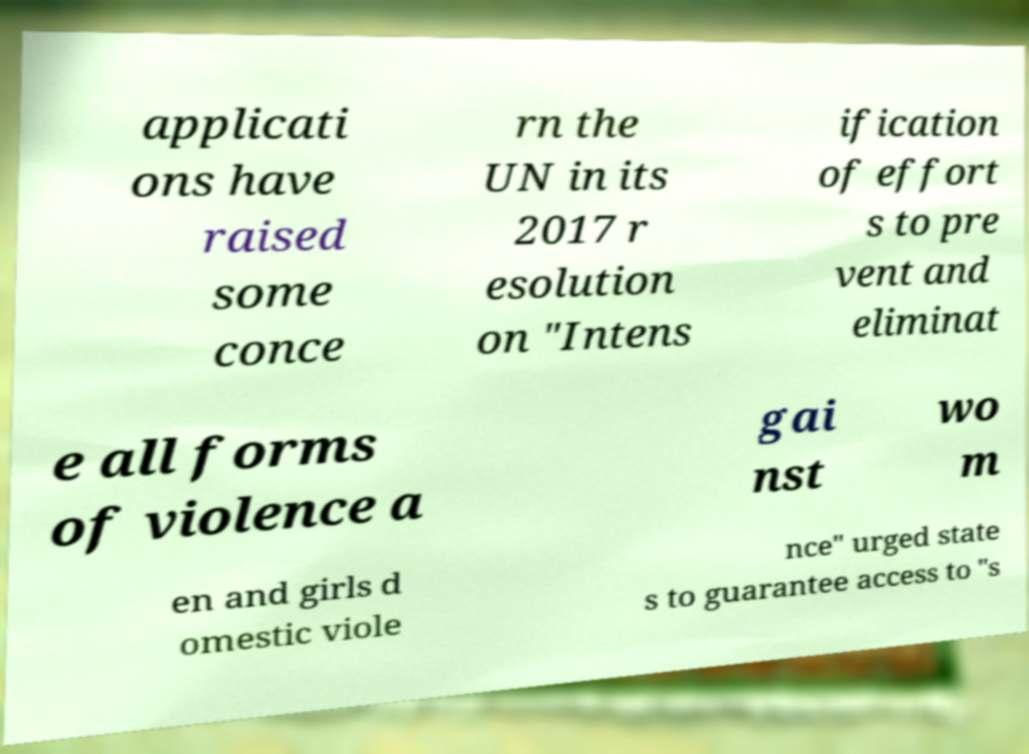Can you accurately transcribe the text from the provided image for me? applicati ons have raised some conce rn the UN in its 2017 r esolution on "Intens ification of effort s to pre vent and eliminat e all forms of violence a gai nst wo m en and girls d omestic viole nce" urged state s to guarantee access to "s 